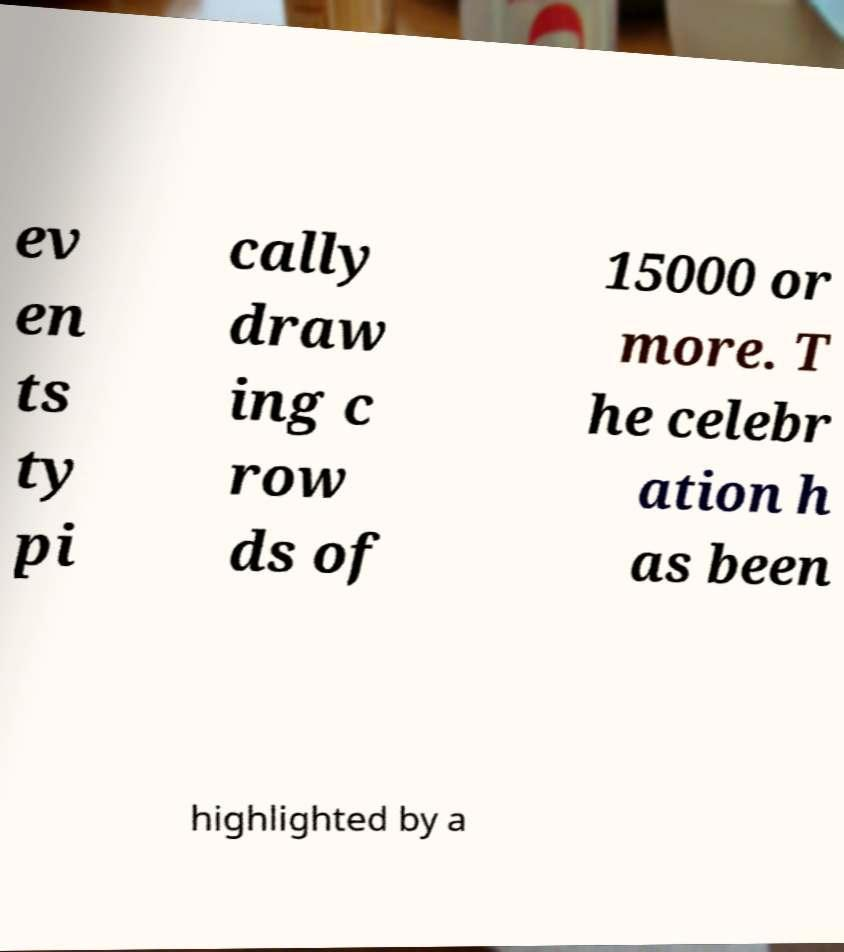Please identify and transcribe the text found in this image. ev en ts ty pi cally draw ing c row ds of 15000 or more. T he celebr ation h as been highlighted by a 